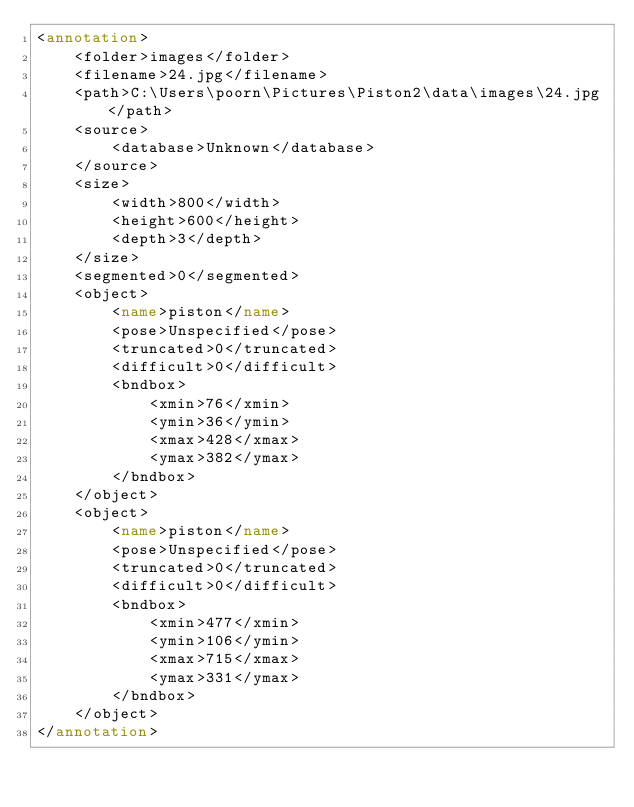Convert code to text. <code><loc_0><loc_0><loc_500><loc_500><_XML_><annotation>
	<folder>images</folder>
	<filename>24.jpg</filename>
	<path>C:\Users\poorn\Pictures\Piston2\data\images\24.jpg</path>
	<source>
		<database>Unknown</database>
	</source>
	<size>
		<width>800</width>
		<height>600</height>
		<depth>3</depth>
	</size>
	<segmented>0</segmented>
	<object>
		<name>piston</name>
		<pose>Unspecified</pose>
		<truncated>0</truncated>
		<difficult>0</difficult>
		<bndbox>
			<xmin>76</xmin>
			<ymin>36</ymin>
			<xmax>428</xmax>
			<ymax>382</ymax>
		</bndbox>
	</object>
	<object>
		<name>piston</name>
		<pose>Unspecified</pose>
		<truncated>0</truncated>
		<difficult>0</difficult>
		<bndbox>
			<xmin>477</xmin>
			<ymin>106</ymin>
			<xmax>715</xmax>
			<ymax>331</ymax>
		</bndbox>
	</object>
</annotation>
</code> 